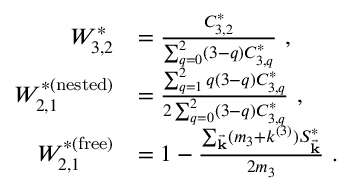Convert formula to latex. <formula><loc_0><loc_0><loc_500><loc_500>\begin{array} { r l } { W _ { 3 , 2 } ^ { * } } & { = \frac { C _ { 3 , 2 } ^ { * } } { \sum _ { q = 0 } ^ { 2 } ( 3 - q ) C _ { 3 , q } ^ { * } } , } \\ { W _ { 2 , 1 } ^ { * ( n e s t e d ) } } & { = \frac { \sum _ { q = 1 } ^ { 2 } q ( 3 - q ) C _ { 3 , q } ^ { * } } { 2 \sum _ { q = 0 } ^ { 2 } ( 3 - q ) C _ { 3 , q } ^ { * } } , } \\ { W _ { 2 , 1 } ^ { * ( f r e e ) } } & { = 1 - \frac { \sum _ { \vec { k } } ( m _ { 3 } + k ^ { ( 3 ) } ) S _ { \vec { k } } ^ { * } } { 2 m _ { 3 } } . } \end{array}</formula> 